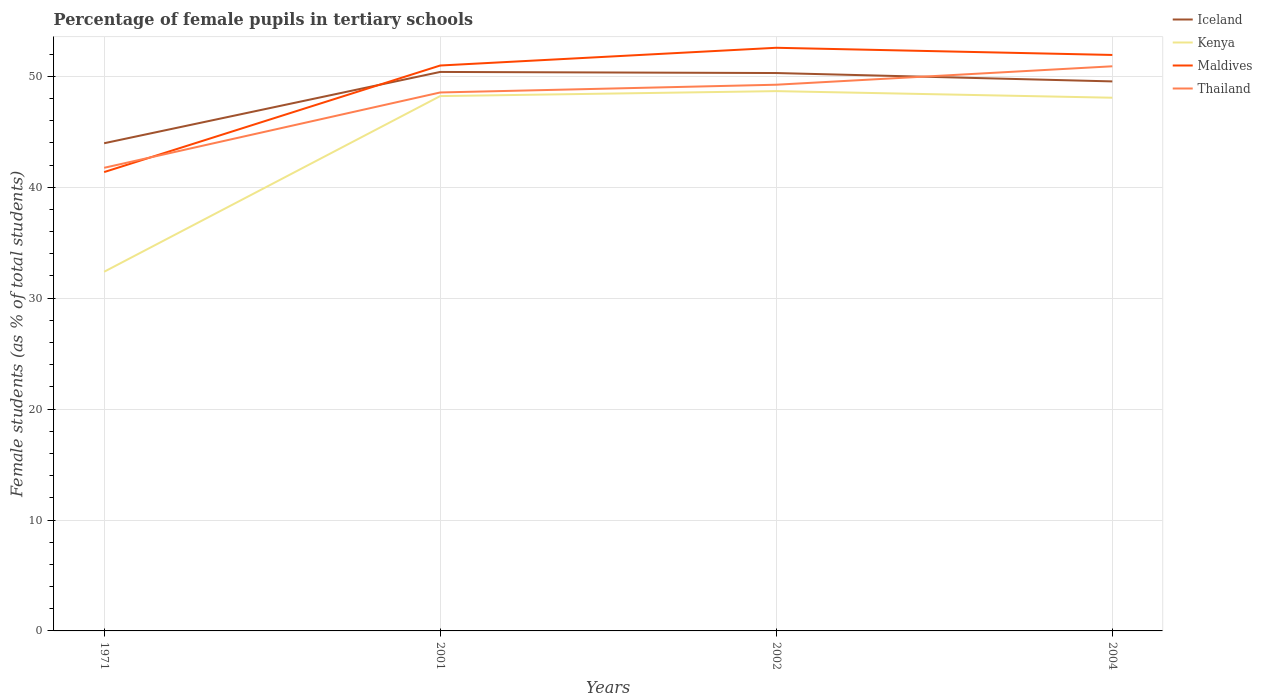How many different coloured lines are there?
Ensure brevity in your answer.  4. Does the line corresponding to Kenya intersect with the line corresponding to Iceland?
Offer a terse response. No. Across all years, what is the maximum percentage of female pupils in tertiary schools in Thailand?
Give a very brief answer. 41.76. What is the total percentage of female pupils in tertiary schools in Kenya in the graph?
Ensure brevity in your answer.  -16.29. What is the difference between the highest and the second highest percentage of female pupils in tertiary schools in Kenya?
Your answer should be compact. 16.29. What is the difference between the highest and the lowest percentage of female pupils in tertiary schools in Thailand?
Your answer should be very brief. 3. How many lines are there?
Your response must be concise. 4. How many years are there in the graph?
Give a very brief answer. 4. What is the difference between two consecutive major ticks on the Y-axis?
Your response must be concise. 10. Does the graph contain grids?
Ensure brevity in your answer.  Yes. Where does the legend appear in the graph?
Make the answer very short. Top right. How many legend labels are there?
Offer a very short reply. 4. What is the title of the graph?
Your response must be concise. Percentage of female pupils in tertiary schools. What is the label or title of the X-axis?
Your answer should be compact. Years. What is the label or title of the Y-axis?
Your answer should be very brief. Female students (as % of total students). What is the Female students (as % of total students) in Iceland in 1971?
Your answer should be very brief. 43.97. What is the Female students (as % of total students) in Kenya in 1971?
Provide a short and direct response. 32.38. What is the Female students (as % of total students) in Maldives in 1971?
Provide a succinct answer. 41.37. What is the Female students (as % of total students) in Thailand in 1971?
Give a very brief answer. 41.76. What is the Female students (as % of total students) in Iceland in 2001?
Make the answer very short. 50.4. What is the Female students (as % of total students) in Kenya in 2001?
Provide a short and direct response. 48.22. What is the Female students (as % of total students) in Maldives in 2001?
Make the answer very short. 50.98. What is the Female students (as % of total students) of Thailand in 2001?
Keep it short and to the point. 48.55. What is the Female students (as % of total students) in Iceland in 2002?
Make the answer very short. 50.3. What is the Female students (as % of total students) in Kenya in 2002?
Your answer should be very brief. 48.67. What is the Female students (as % of total students) of Maldives in 2002?
Provide a succinct answer. 52.58. What is the Female students (as % of total students) in Thailand in 2002?
Ensure brevity in your answer.  49.25. What is the Female students (as % of total students) in Iceland in 2004?
Ensure brevity in your answer.  49.54. What is the Female students (as % of total students) of Kenya in 2004?
Your response must be concise. 48.07. What is the Female students (as % of total students) in Maldives in 2004?
Make the answer very short. 51.93. What is the Female students (as % of total students) of Thailand in 2004?
Offer a terse response. 50.91. Across all years, what is the maximum Female students (as % of total students) in Iceland?
Your response must be concise. 50.4. Across all years, what is the maximum Female students (as % of total students) of Kenya?
Your response must be concise. 48.67. Across all years, what is the maximum Female students (as % of total students) of Maldives?
Provide a short and direct response. 52.58. Across all years, what is the maximum Female students (as % of total students) in Thailand?
Offer a terse response. 50.91. Across all years, what is the minimum Female students (as % of total students) in Iceland?
Offer a very short reply. 43.97. Across all years, what is the minimum Female students (as % of total students) of Kenya?
Provide a succinct answer. 32.38. Across all years, what is the minimum Female students (as % of total students) in Maldives?
Provide a succinct answer. 41.37. Across all years, what is the minimum Female students (as % of total students) in Thailand?
Offer a very short reply. 41.76. What is the total Female students (as % of total students) in Iceland in the graph?
Your response must be concise. 194.21. What is the total Female students (as % of total students) in Kenya in the graph?
Keep it short and to the point. 177.34. What is the total Female students (as % of total students) in Maldives in the graph?
Provide a succinct answer. 196.85. What is the total Female students (as % of total students) of Thailand in the graph?
Keep it short and to the point. 190.45. What is the difference between the Female students (as % of total students) in Iceland in 1971 and that in 2001?
Your answer should be very brief. -6.43. What is the difference between the Female students (as % of total students) in Kenya in 1971 and that in 2001?
Your answer should be very brief. -15.84. What is the difference between the Female students (as % of total students) in Maldives in 1971 and that in 2001?
Provide a short and direct response. -9.61. What is the difference between the Female students (as % of total students) of Thailand in 1971 and that in 2001?
Provide a short and direct response. -6.79. What is the difference between the Female students (as % of total students) of Iceland in 1971 and that in 2002?
Your response must be concise. -6.33. What is the difference between the Female students (as % of total students) of Kenya in 1971 and that in 2002?
Offer a very short reply. -16.29. What is the difference between the Female students (as % of total students) in Maldives in 1971 and that in 2002?
Your response must be concise. -11.21. What is the difference between the Female students (as % of total students) in Thailand in 1971 and that in 2002?
Offer a very short reply. -7.49. What is the difference between the Female students (as % of total students) in Iceland in 1971 and that in 2004?
Your answer should be very brief. -5.58. What is the difference between the Female students (as % of total students) of Kenya in 1971 and that in 2004?
Offer a terse response. -15.69. What is the difference between the Female students (as % of total students) of Maldives in 1971 and that in 2004?
Your answer should be compact. -10.56. What is the difference between the Female students (as % of total students) in Thailand in 1971 and that in 2004?
Give a very brief answer. -9.15. What is the difference between the Female students (as % of total students) of Iceland in 2001 and that in 2002?
Provide a succinct answer. 0.1. What is the difference between the Female students (as % of total students) of Kenya in 2001 and that in 2002?
Provide a short and direct response. -0.45. What is the difference between the Female students (as % of total students) of Maldives in 2001 and that in 2002?
Your response must be concise. -1.6. What is the difference between the Female students (as % of total students) in Thailand in 2001 and that in 2002?
Your answer should be very brief. -0.7. What is the difference between the Female students (as % of total students) in Iceland in 2001 and that in 2004?
Provide a succinct answer. 0.85. What is the difference between the Female students (as % of total students) in Kenya in 2001 and that in 2004?
Your answer should be very brief. 0.15. What is the difference between the Female students (as % of total students) in Maldives in 2001 and that in 2004?
Provide a short and direct response. -0.95. What is the difference between the Female students (as % of total students) of Thailand in 2001 and that in 2004?
Give a very brief answer. -2.36. What is the difference between the Female students (as % of total students) of Iceland in 2002 and that in 2004?
Give a very brief answer. 0.75. What is the difference between the Female students (as % of total students) in Kenya in 2002 and that in 2004?
Your answer should be compact. 0.59. What is the difference between the Female students (as % of total students) in Maldives in 2002 and that in 2004?
Provide a short and direct response. 0.65. What is the difference between the Female students (as % of total students) in Thailand in 2002 and that in 2004?
Provide a short and direct response. -1.66. What is the difference between the Female students (as % of total students) of Iceland in 1971 and the Female students (as % of total students) of Kenya in 2001?
Your answer should be very brief. -4.25. What is the difference between the Female students (as % of total students) of Iceland in 1971 and the Female students (as % of total students) of Maldives in 2001?
Offer a terse response. -7.01. What is the difference between the Female students (as % of total students) of Iceland in 1971 and the Female students (as % of total students) of Thailand in 2001?
Ensure brevity in your answer.  -4.58. What is the difference between the Female students (as % of total students) in Kenya in 1971 and the Female students (as % of total students) in Maldives in 2001?
Offer a terse response. -18.6. What is the difference between the Female students (as % of total students) in Kenya in 1971 and the Female students (as % of total students) in Thailand in 2001?
Ensure brevity in your answer.  -16.16. What is the difference between the Female students (as % of total students) of Maldives in 1971 and the Female students (as % of total students) of Thailand in 2001?
Provide a short and direct response. -7.18. What is the difference between the Female students (as % of total students) of Iceland in 1971 and the Female students (as % of total students) of Kenya in 2002?
Your answer should be very brief. -4.7. What is the difference between the Female students (as % of total students) in Iceland in 1971 and the Female students (as % of total students) in Maldives in 2002?
Provide a short and direct response. -8.61. What is the difference between the Female students (as % of total students) in Iceland in 1971 and the Female students (as % of total students) in Thailand in 2002?
Offer a terse response. -5.28. What is the difference between the Female students (as % of total students) in Kenya in 1971 and the Female students (as % of total students) in Maldives in 2002?
Your response must be concise. -20.19. What is the difference between the Female students (as % of total students) in Kenya in 1971 and the Female students (as % of total students) in Thailand in 2002?
Provide a succinct answer. -16.86. What is the difference between the Female students (as % of total students) of Maldives in 1971 and the Female students (as % of total students) of Thailand in 2002?
Ensure brevity in your answer.  -7.88. What is the difference between the Female students (as % of total students) in Iceland in 1971 and the Female students (as % of total students) in Kenya in 2004?
Provide a succinct answer. -4.11. What is the difference between the Female students (as % of total students) in Iceland in 1971 and the Female students (as % of total students) in Maldives in 2004?
Your response must be concise. -7.96. What is the difference between the Female students (as % of total students) of Iceland in 1971 and the Female students (as % of total students) of Thailand in 2004?
Give a very brief answer. -6.94. What is the difference between the Female students (as % of total students) in Kenya in 1971 and the Female students (as % of total students) in Maldives in 2004?
Your response must be concise. -19.55. What is the difference between the Female students (as % of total students) in Kenya in 1971 and the Female students (as % of total students) in Thailand in 2004?
Offer a terse response. -18.53. What is the difference between the Female students (as % of total students) in Maldives in 1971 and the Female students (as % of total students) in Thailand in 2004?
Offer a very short reply. -9.54. What is the difference between the Female students (as % of total students) in Iceland in 2001 and the Female students (as % of total students) in Kenya in 2002?
Offer a terse response. 1.73. What is the difference between the Female students (as % of total students) in Iceland in 2001 and the Female students (as % of total students) in Maldives in 2002?
Offer a terse response. -2.18. What is the difference between the Female students (as % of total students) in Iceland in 2001 and the Female students (as % of total students) in Thailand in 2002?
Make the answer very short. 1.15. What is the difference between the Female students (as % of total students) in Kenya in 2001 and the Female students (as % of total students) in Maldives in 2002?
Your response must be concise. -4.36. What is the difference between the Female students (as % of total students) of Kenya in 2001 and the Female students (as % of total students) of Thailand in 2002?
Your answer should be very brief. -1.03. What is the difference between the Female students (as % of total students) of Maldives in 2001 and the Female students (as % of total students) of Thailand in 2002?
Your response must be concise. 1.73. What is the difference between the Female students (as % of total students) in Iceland in 2001 and the Female students (as % of total students) in Kenya in 2004?
Your response must be concise. 2.32. What is the difference between the Female students (as % of total students) of Iceland in 2001 and the Female students (as % of total students) of Maldives in 2004?
Keep it short and to the point. -1.53. What is the difference between the Female students (as % of total students) in Iceland in 2001 and the Female students (as % of total students) in Thailand in 2004?
Make the answer very short. -0.51. What is the difference between the Female students (as % of total students) of Kenya in 2001 and the Female students (as % of total students) of Maldives in 2004?
Your answer should be very brief. -3.71. What is the difference between the Female students (as % of total students) in Kenya in 2001 and the Female students (as % of total students) in Thailand in 2004?
Keep it short and to the point. -2.69. What is the difference between the Female students (as % of total students) in Maldives in 2001 and the Female students (as % of total students) in Thailand in 2004?
Your response must be concise. 0.07. What is the difference between the Female students (as % of total students) of Iceland in 2002 and the Female students (as % of total students) of Kenya in 2004?
Offer a very short reply. 2.22. What is the difference between the Female students (as % of total students) of Iceland in 2002 and the Female students (as % of total students) of Maldives in 2004?
Provide a succinct answer. -1.63. What is the difference between the Female students (as % of total students) of Iceland in 2002 and the Female students (as % of total students) of Thailand in 2004?
Offer a very short reply. -0.61. What is the difference between the Female students (as % of total students) in Kenya in 2002 and the Female students (as % of total students) in Maldives in 2004?
Offer a very short reply. -3.26. What is the difference between the Female students (as % of total students) of Kenya in 2002 and the Female students (as % of total students) of Thailand in 2004?
Offer a very short reply. -2.24. What is the difference between the Female students (as % of total students) of Maldives in 2002 and the Female students (as % of total students) of Thailand in 2004?
Your answer should be compact. 1.67. What is the average Female students (as % of total students) in Iceland per year?
Give a very brief answer. 48.55. What is the average Female students (as % of total students) of Kenya per year?
Offer a terse response. 44.34. What is the average Female students (as % of total students) of Maldives per year?
Give a very brief answer. 49.21. What is the average Female students (as % of total students) of Thailand per year?
Offer a very short reply. 47.61. In the year 1971, what is the difference between the Female students (as % of total students) in Iceland and Female students (as % of total students) in Kenya?
Your answer should be very brief. 11.59. In the year 1971, what is the difference between the Female students (as % of total students) in Iceland and Female students (as % of total students) in Maldives?
Provide a succinct answer. 2.6. In the year 1971, what is the difference between the Female students (as % of total students) of Iceland and Female students (as % of total students) of Thailand?
Ensure brevity in your answer.  2.21. In the year 1971, what is the difference between the Female students (as % of total students) in Kenya and Female students (as % of total students) in Maldives?
Offer a very short reply. -8.99. In the year 1971, what is the difference between the Female students (as % of total students) of Kenya and Female students (as % of total students) of Thailand?
Your response must be concise. -9.37. In the year 1971, what is the difference between the Female students (as % of total students) of Maldives and Female students (as % of total students) of Thailand?
Provide a short and direct response. -0.39. In the year 2001, what is the difference between the Female students (as % of total students) in Iceland and Female students (as % of total students) in Kenya?
Keep it short and to the point. 2.18. In the year 2001, what is the difference between the Female students (as % of total students) in Iceland and Female students (as % of total students) in Maldives?
Your answer should be very brief. -0.58. In the year 2001, what is the difference between the Female students (as % of total students) of Iceland and Female students (as % of total students) of Thailand?
Your response must be concise. 1.85. In the year 2001, what is the difference between the Female students (as % of total students) of Kenya and Female students (as % of total students) of Maldives?
Offer a very short reply. -2.76. In the year 2001, what is the difference between the Female students (as % of total students) of Kenya and Female students (as % of total students) of Thailand?
Your answer should be compact. -0.33. In the year 2001, what is the difference between the Female students (as % of total students) of Maldives and Female students (as % of total students) of Thailand?
Give a very brief answer. 2.43. In the year 2002, what is the difference between the Female students (as % of total students) of Iceland and Female students (as % of total students) of Kenya?
Keep it short and to the point. 1.63. In the year 2002, what is the difference between the Female students (as % of total students) in Iceland and Female students (as % of total students) in Maldives?
Provide a succinct answer. -2.28. In the year 2002, what is the difference between the Female students (as % of total students) of Iceland and Female students (as % of total students) of Thailand?
Give a very brief answer. 1.05. In the year 2002, what is the difference between the Female students (as % of total students) of Kenya and Female students (as % of total students) of Maldives?
Make the answer very short. -3.91. In the year 2002, what is the difference between the Female students (as % of total students) in Kenya and Female students (as % of total students) in Thailand?
Provide a short and direct response. -0.58. In the year 2002, what is the difference between the Female students (as % of total students) in Maldives and Female students (as % of total students) in Thailand?
Your answer should be very brief. 3.33. In the year 2004, what is the difference between the Female students (as % of total students) of Iceland and Female students (as % of total students) of Kenya?
Offer a very short reply. 1.47. In the year 2004, what is the difference between the Female students (as % of total students) in Iceland and Female students (as % of total students) in Maldives?
Provide a succinct answer. -2.38. In the year 2004, what is the difference between the Female students (as % of total students) in Iceland and Female students (as % of total students) in Thailand?
Keep it short and to the point. -1.36. In the year 2004, what is the difference between the Female students (as % of total students) in Kenya and Female students (as % of total students) in Maldives?
Your response must be concise. -3.85. In the year 2004, what is the difference between the Female students (as % of total students) of Kenya and Female students (as % of total students) of Thailand?
Provide a succinct answer. -2.83. In the year 2004, what is the difference between the Female students (as % of total students) of Maldives and Female students (as % of total students) of Thailand?
Offer a very short reply. 1.02. What is the ratio of the Female students (as % of total students) of Iceland in 1971 to that in 2001?
Your answer should be very brief. 0.87. What is the ratio of the Female students (as % of total students) in Kenya in 1971 to that in 2001?
Your answer should be compact. 0.67. What is the ratio of the Female students (as % of total students) of Maldives in 1971 to that in 2001?
Your answer should be compact. 0.81. What is the ratio of the Female students (as % of total students) in Thailand in 1971 to that in 2001?
Your answer should be very brief. 0.86. What is the ratio of the Female students (as % of total students) of Iceland in 1971 to that in 2002?
Make the answer very short. 0.87. What is the ratio of the Female students (as % of total students) of Kenya in 1971 to that in 2002?
Provide a short and direct response. 0.67. What is the ratio of the Female students (as % of total students) in Maldives in 1971 to that in 2002?
Provide a succinct answer. 0.79. What is the ratio of the Female students (as % of total students) of Thailand in 1971 to that in 2002?
Your response must be concise. 0.85. What is the ratio of the Female students (as % of total students) in Iceland in 1971 to that in 2004?
Provide a short and direct response. 0.89. What is the ratio of the Female students (as % of total students) of Kenya in 1971 to that in 2004?
Offer a terse response. 0.67. What is the ratio of the Female students (as % of total students) in Maldives in 1971 to that in 2004?
Offer a terse response. 0.8. What is the ratio of the Female students (as % of total students) in Thailand in 1971 to that in 2004?
Your answer should be very brief. 0.82. What is the ratio of the Female students (as % of total students) of Kenya in 2001 to that in 2002?
Offer a very short reply. 0.99. What is the ratio of the Female students (as % of total students) of Maldives in 2001 to that in 2002?
Provide a succinct answer. 0.97. What is the ratio of the Female students (as % of total students) of Thailand in 2001 to that in 2002?
Your response must be concise. 0.99. What is the ratio of the Female students (as % of total students) of Iceland in 2001 to that in 2004?
Offer a terse response. 1.02. What is the ratio of the Female students (as % of total students) of Maldives in 2001 to that in 2004?
Provide a succinct answer. 0.98. What is the ratio of the Female students (as % of total students) of Thailand in 2001 to that in 2004?
Offer a very short reply. 0.95. What is the ratio of the Female students (as % of total students) in Iceland in 2002 to that in 2004?
Provide a short and direct response. 1.02. What is the ratio of the Female students (as % of total students) in Kenya in 2002 to that in 2004?
Make the answer very short. 1.01. What is the ratio of the Female students (as % of total students) of Maldives in 2002 to that in 2004?
Offer a very short reply. 1.01. What is the ratio of the Female students (as % of total students) of Thailand in 2002 to that in 2004?
Keep it short and to the point. 0.97. What is the difference between the highest and the second highest Female students (as % of total students) of Iceland?
Your response must be concise. 0.1. What is the difference between the highest and the second highest Female students (as % of total students) of Kenya?
Make the answer very short. 0.45. What is the difference between the highest and the second highest Female students (as % of total students) of Maldives?
Keep it short and to the point. 0.65. What is the difference between the highest and the second highest Female students (as % of total students) in Thailand?
Offer a very short reply. 1.66. What is the difference between the highest and the lowest Female students (as % of total students) of Iceland?
Ensure brevity in your answer.  6.43. What is the difference between the highest and the lowest Female students (as % of total students) in Kenya?
Keep it short and to the point. 16.29. What is the difference between the highest and the lowest Female students (as % of total students) of Maldives?
Provide a succinct answer. 11.21. What is the difference between the highest and the lowest Female students (as % of total students) in Thailand?
Ensure brevity in your answer.  9.15. 